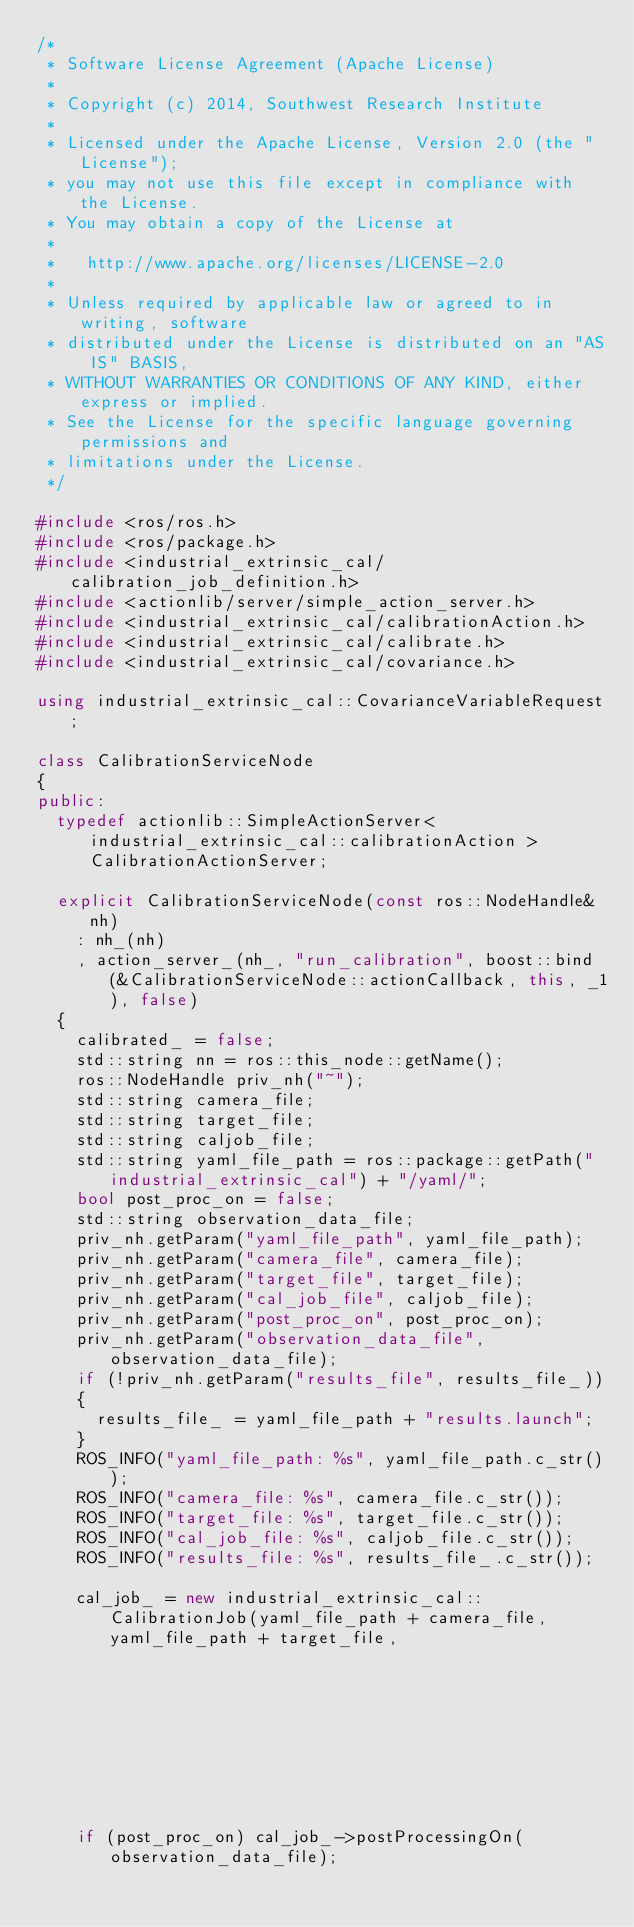Convert code to text. <code><loc_0><loc_0><loc_500><loc_500><_C++_>/*
 * Software License Agreement (Apache License)
 *
 * Copyright (c) 2014, Southwest Research Institute
 *
 * Licensed under the Apache License, Version 2.0 (the "License");
 * you may not use this file except in compliance with the License.
 * You may obtain a copy of the License at
 *
 *   http://www.apache.org/licenses/LICENSE-2.0
 *
 * Unless required by applicable law or agreed to in writing, software
 * distributed under the License is distributed on an "AS IS" BASIS,
 * WITHOUT WARRANTIES OR CONDITIONS OF ANY KIND, either express or implied.
 * See the License for the specific language governing permissions and
 * limitations under the License.
 */

#include <ros/ros.h>
#include <ros/package.h>
#include <industrial_extrinsic_cal/calibration_job_definition.h>
#include <actionlib/server/simple_action_server.h>
#include <industrial_extrinsic_cal/calibrationAction.h>
#include <industrial_extrinsic_cal/calibrate.h>
#include <industrial_extrinsic_cal/covariance.h>

using industrial_extrinsic_cal::CovarianceVariableRequest;

class CalibrationServiceNode
{
public:
  typedef actionlib::SimpleActionServer< industrial_extrinsic_cal::calibrationAction > CalibrationActionServer;

  explicit CalibrationServiceNode(const ros::NodeHandle& nh)
    : nh_(nh)
    , action_server_(nh_, "run_calibration", boost::bind(&CalibrationServiceNode::actionCallback, this, _1), false)
  {
    calibrated_ = false;
    std::string nn = ros::this_node::getName();
    ros::NodeHandle priv_nh("~");
    std::string camera_file;
    std::string target_file;
    std::string caljob_file;
    std::string yaml_file_path = ros::package::getPath("industrial_extrinsic_cal") + "/yaml/";
    bool post_proc_on = false;
    std::string observation_data_file;
    priv_nh.getParam("yaml_file_path", yaml_file_path);
    priv_nh.getParam("camera_file", camera_file);
    priv_nh.getParam("target_file", target_file);
    priv_nh.getParam("cal_job_file", caljob_file);
    priv_nh.getParam("post_proc_on", post_proc_on);
    priv_nh.getParam("observation_data_file", observation_data_file);
    if (!priv_nh.getParam("results_file", results_file_))
    {
      results_file_ = yaml_file_path + "results.launch";
    }
    ROS_INFO("yaml_file_path: %s", yaml_file_path.c_str());
    ROS_INFO("camera_file: %s", camera_file.c_str());
    ROS_INFO("target_file: %s", target_file.c_str());
    ROS_INFO("cal_job_file: %s", caljob_file.c_str());
    ROS_INFO("results_file: %s", results_file_.c_str());

    cal_job_ = new industrial_extrinsic_cal::CalibrationJob(yaml_file_path + camera_file, yaml_file_path + target_file,
                                                            yaml_file_path + caljob_file);

    if (post_proc_on) cal_job_->postProcessingOn(observation_data_file);</code> 